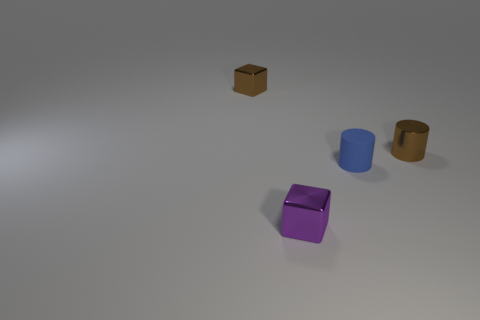Subtract all gray cylinders. How many blue cubes are left? 0 Add 3 green cylinders. How many objects exist? 7 Subtract all brown cylinders. How many cylinders are left? 1 Subtract 1 blocks. How many blocks are left? 1 Add 3 tiny shiny things. How many tiny shiny things are left? 6 Add 4 small yellow metal balls. How many small yellow metal balls exist? 4 Subtract 1 blue cylinders. How many objects are left? 3 Subtract all cyan cylinders. Subtract all green balls. How many cylinders are left? 2 Subtract all brown objects. Subtract all small matte cylinders. How many objects are left? 1 